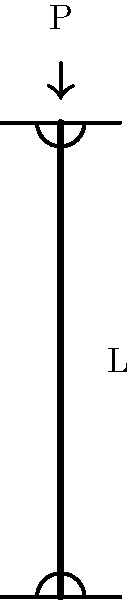Consider a column with pinned-pinned end conditions, as shown in the figure. The column has a length $L$, elastic modulus $E$, and moment of inertia $I$. What is the expression for the critical buckling load $P_{cr}$ for this column? To determine the critical buckling load for a column with pinned-pinned end conditions, we can follow these steps:

1. Recall Euler's formula for critical buckling load:
   $$P_{cr} = \frac{\pi^2 EI}{(KL)^2}$$
   where $K$ is the effective length factor.

2. For a pinned-pinned column, the effective length factor $K = 1$. This means the effective length is equal to the actual length of the column.

3. Substituting $K = 1$ into Euler's formula:
   $$P_{cr} = \frac{\pi^2 EI}{L^2}$$

4. This expression gives us the critical buckling load for a pinned-pinned column in terms of its material properties ($E$, $I$) and geometry ($L$).

5. It's worth noting that this formula assumes:
   - The column is perfectly straight
   - The material is homogeneous and isotropic
   - The load is applied axially
   - The column fails by elastic buckling

6. In practice, engineers often include a factor of safety when designing columns to account for imperfections and uncertainties.
Answer: $P_{cr} = \frac{\pi^2 EI}{L^2}$ 